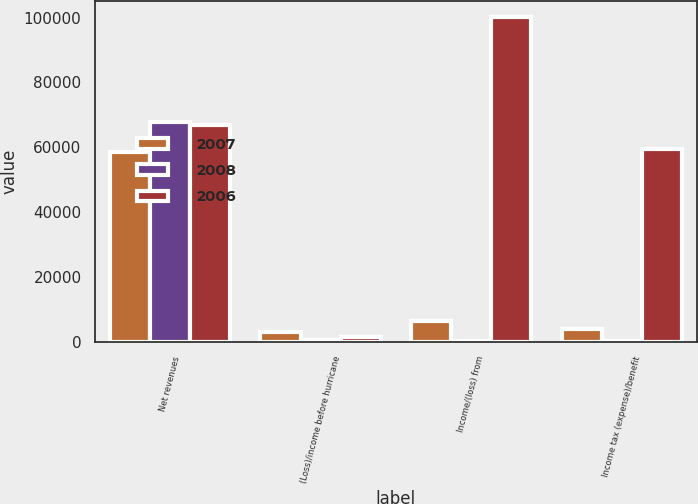<chart> <loc_0><loc_0><loc_500><loc_500><stacked_bar_chart><ecel><fcel>Net revenues<fcel>(Loss)/income before hurricane<fcel>Income/(loss) from<fcel>Income tax (expense)/benefit<nl><fcel>2007<fcel>58467<fcel>2996<fcel>6436<fcel>3981<nl><fcel>2008<fcel>67887<fcel>398<fcel>255<fcel>156<nl><fcel>2006<fcel>66823<fcel>1371<fcel>100258<fcel>59580<nl></chart> 